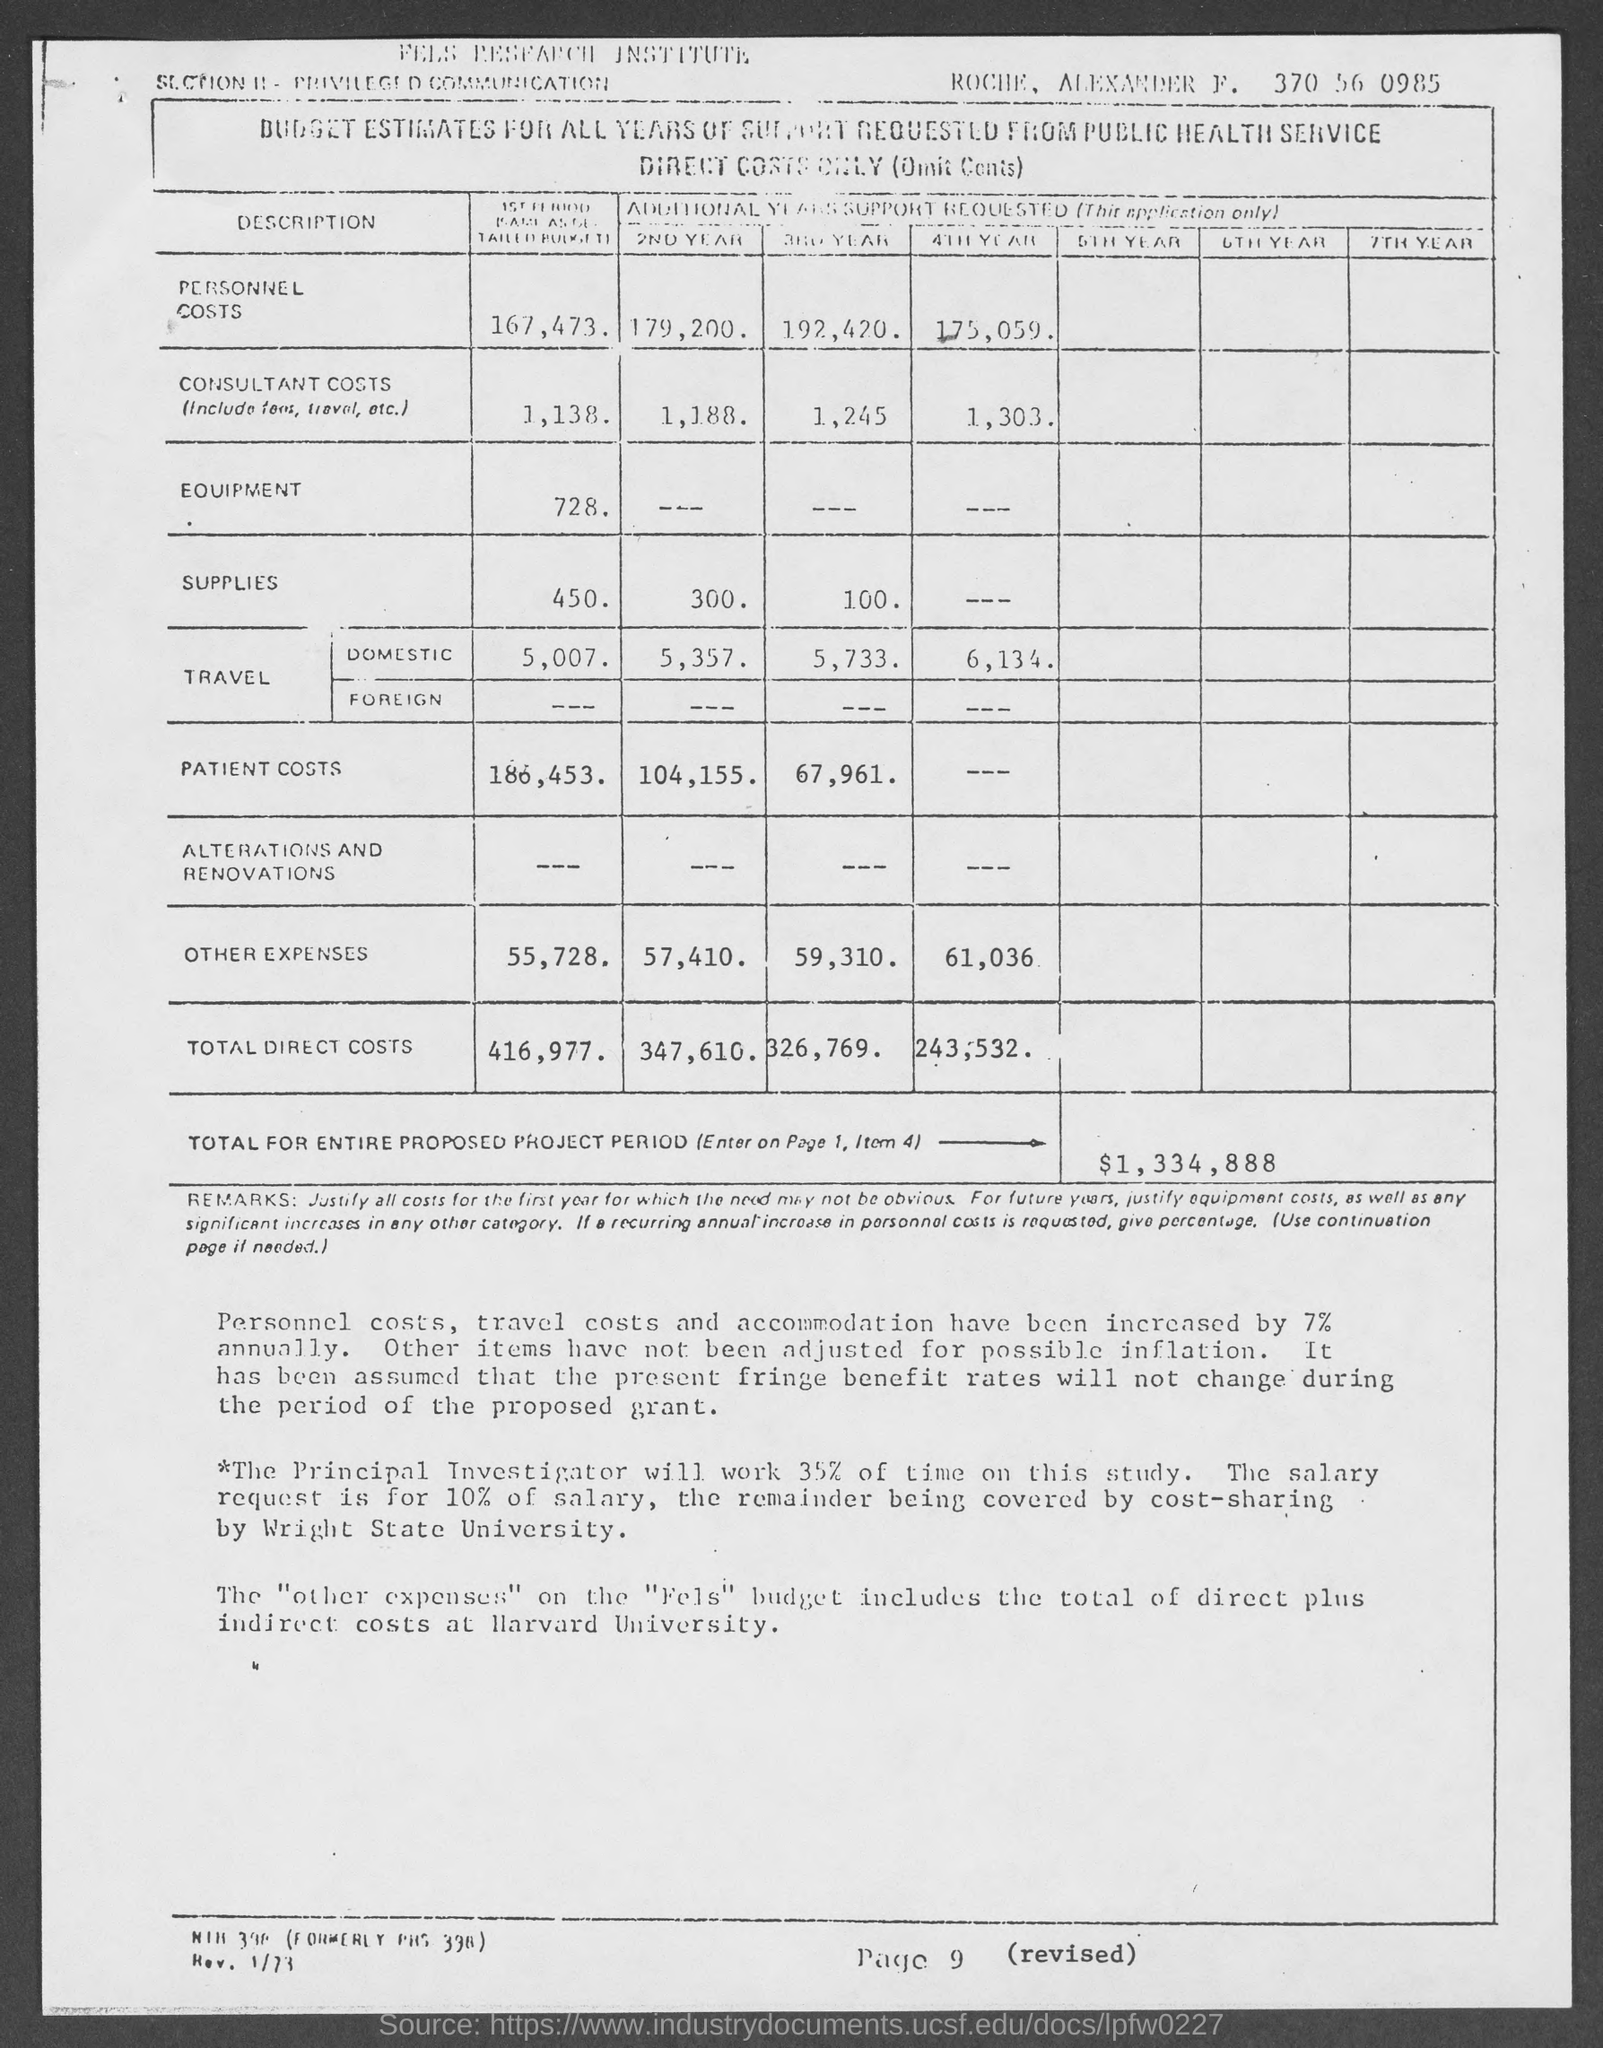Outline some significant characteristics in this image. The page number at the bottom of the page is 9. The proposed project's total amount for the entire project period is $1,334,888. 